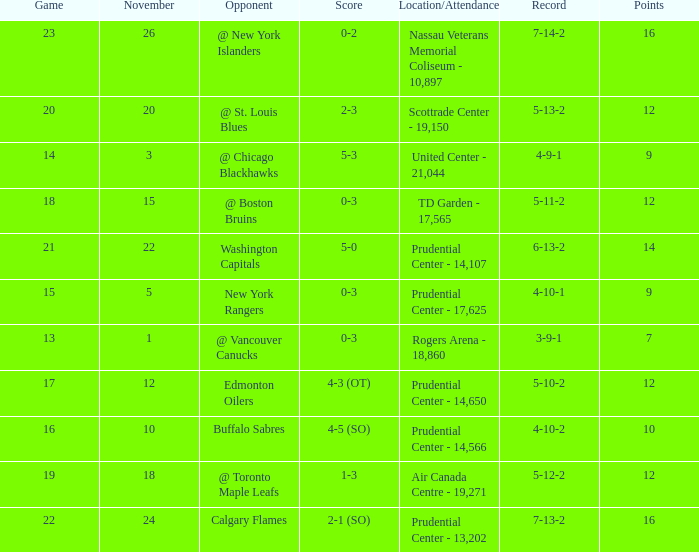What is the record that had a score of 5-3? 4-9-1. 